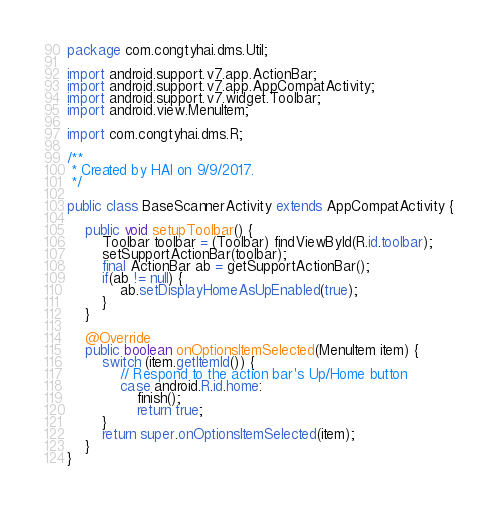Convert code to text. <code><loc_0><loc_0><loc_500><loc_500><_Java_>package com.congtyhai.dms.Util;

import android.support.v7.app.ActionBar;
import android.support.v7.app.AppCompatActivity;
import android.support.v7.widget.Toolbar;
import android.view.MenuItem;

import com.congtyhai.dms.R;

/**
 * Created by HAI on 9/9/2017.
 */

public class BaseScannerActivity extends AppCompatActivity {

    public void setupToolbar() {
        Toolbar toolbar = (Toolbar) findViewById(R.id.toolbar);
        setSupportActionBar(toolbar);
        final ActionBar ab = getSupportActionBar();
        if(ab != null) {
            ab.setDisplayHomeAsUpEnabled(true);
        }
    }

    @Override
    public boolean onOptionsItemSelected(MenuItem item) {
        switch (item.getItemId()) {
            // Respond to the action bar's Up/Home button
            case android.R.id.home:
                finish();
                return true;
        }
        return super.onOptionsItemSelected(item);
    }
}
</code> 